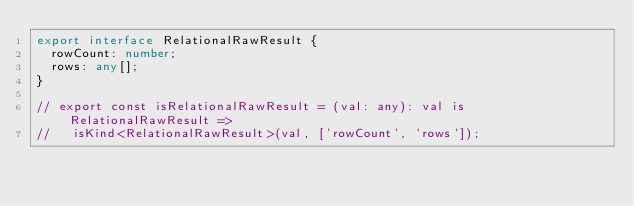<code> <loc_0><loc_0><loc_500><loc_500><_TypeScript_>export interface RelationalRawResult {
  rowCount: number;
  rows: any[];
}

// export const isRelationalRawResult = (val: any): val is RelationalRawResult =>
//   isKind<RelationalRawResult>(val, ['rowCount', 'rows']);
</code> 